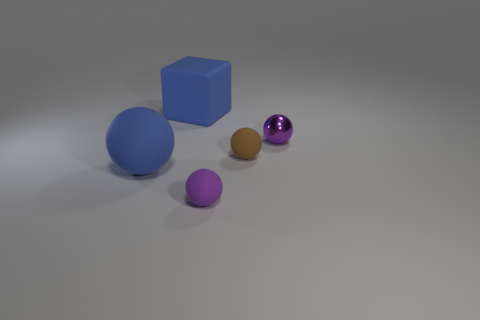Add 4 small green matte spheres. How many objects exist? 9 Subtract all blocks. How many objects are left? 4 Subtract all small brown metallic balls. Subtract all brown matte spheres. How many objects are left? 4 Add 4 purple rubber objects. How many purple rubber objects are left? 5 Add 3 tiny metallic balls. How many tiny metallic balls exist? 4 Subtract 1 blue spheres. How many objects are left? 4 